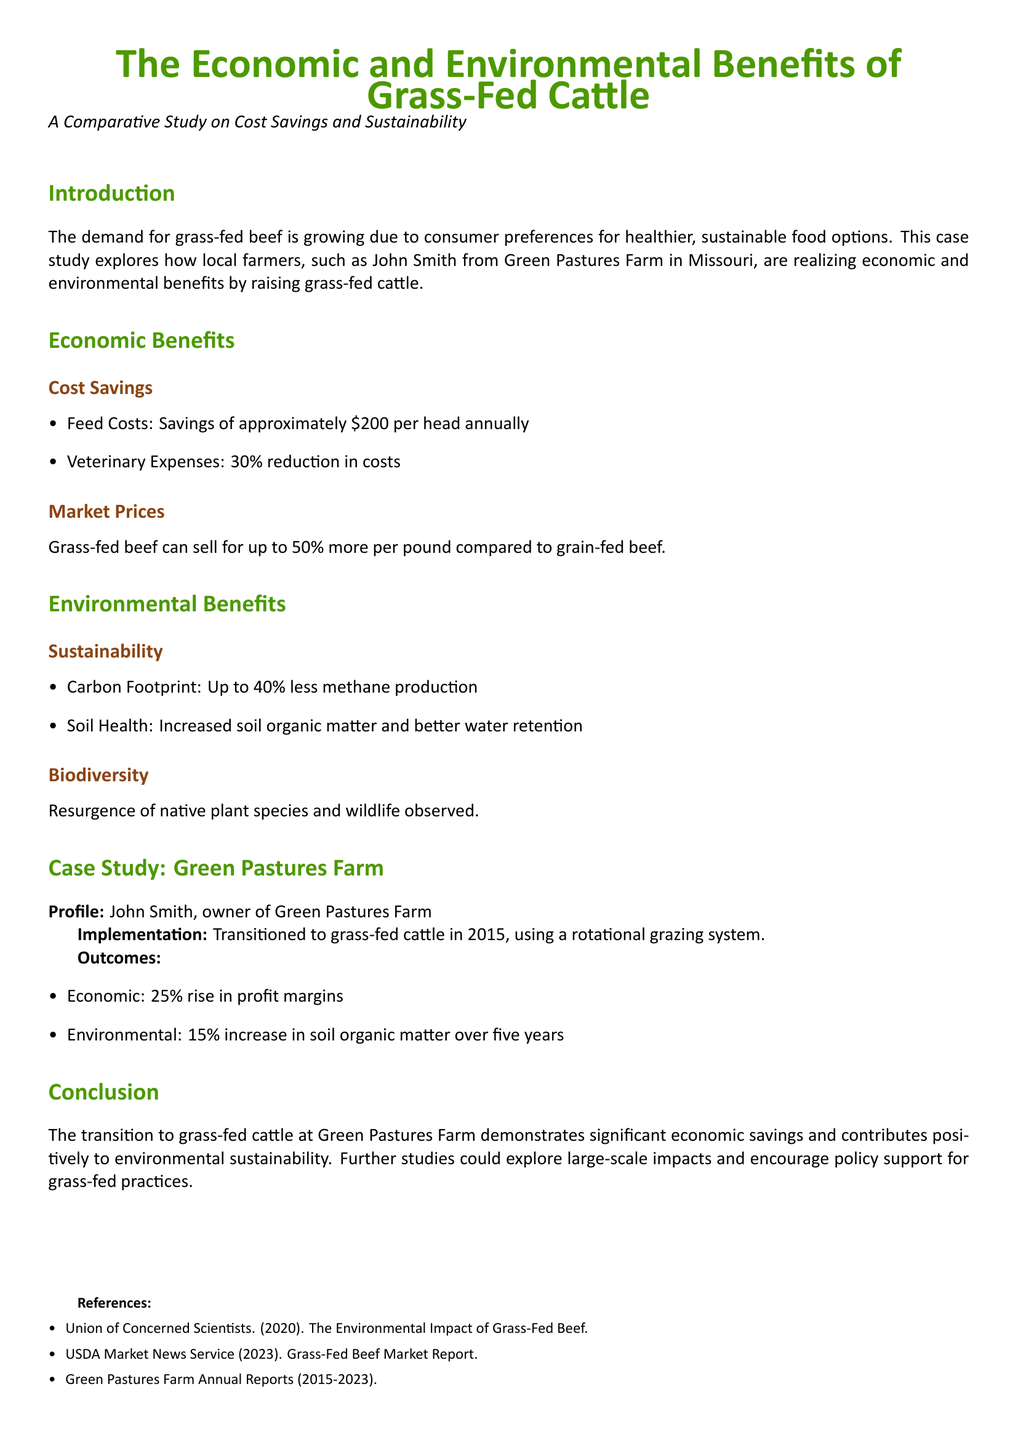What are the savings in feed costs per head annually? The savings in feed costs are specified in the document, which states approximately $200 per head annually.
Answer: $200 What percentage reduction is observed in veterinary expenses? The document notes a 30% reduction in veterinary expenses, which is a specific metric regarding economic benefits.
Answer: 30% How much more can grass-fed beef sell for per pound compared to grain-fed beef? According to the document, grass-fed beef can sell for up to 50% more per pound compared to grain-fed beef.
Answer: 50% What is the percentage decrease in methane production associated with grass-fed cattle? The document presents that grass-fed cattle produce up to 40% less methane, which indicates an environmental benefit.
Answer: 40% What year did John Smith transition to grass-fed cattle? The document specifies that John Smith transitioned to grass-fed cattle in 2015, which is crucial information about the case study timeline.
Answer: 2015 What is the percentage increase in profit margins at Green Pastures Farm? The outcomes from Green Pastures Farm indicate a 25% rise in profit margins, representing economic success from the transition.
Answer: 25% What environmental benefit is associated with soil health? The document states an increase in soil organic matter and better water retention, highlighting the environmental improvements achieved.
Answer: Soil organic matter What is the observed increase in soil organic matter over five years? According to the document, there is a 15% increase in soil organic matter at Green Pastures Farm over five years following the transition.
Answer: 15% What method did John Smith use for cattle grazing? The document specifically states that a rotational grazing system was utilized for cattle grazing at Green Pastures Farm.
Answer: Rotational grazing system What is a potential area for further studies mentioned in the conclusion? The conclusion suggests exploring large-scale impacts and encouraging policy support for grass-fed practices as a recommendation for future research.
Answer: Large-scale impacts 